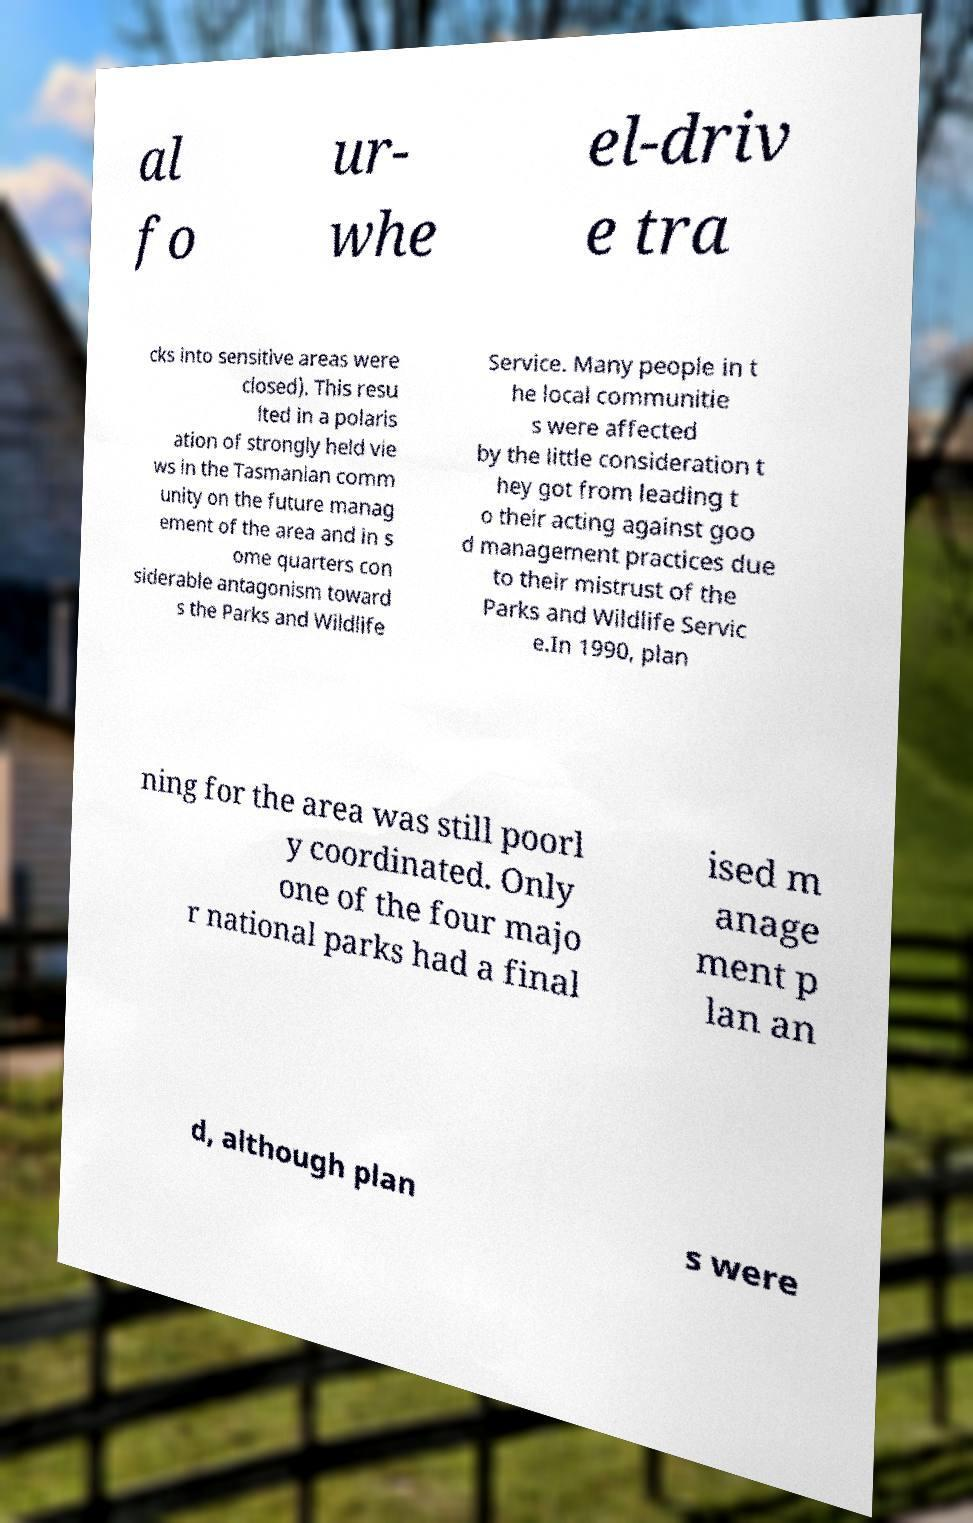I need the written content from this picture converted into text. Can you do that? al fo ur- whe el-driv e tra cks into sensitive areas were closed). This resu lted in a polaris ation of strongly held vie ws in the Tasmanian comm unity on the future manag ement of the area and in s ome quarters con siderable antagonism toward s the Parks and Wildlife Service. Many people in t he local communitie s were affected by the little consideration t hey got from leading t o their acting against goo d management practices due to their mistrust of the Parks and Wildlife Servic e.In 1990, plan ning for the area was still poorl y coordinated. Only one of the four majo r national parks had a final ised m anage ment p lan an d, although plan s were 